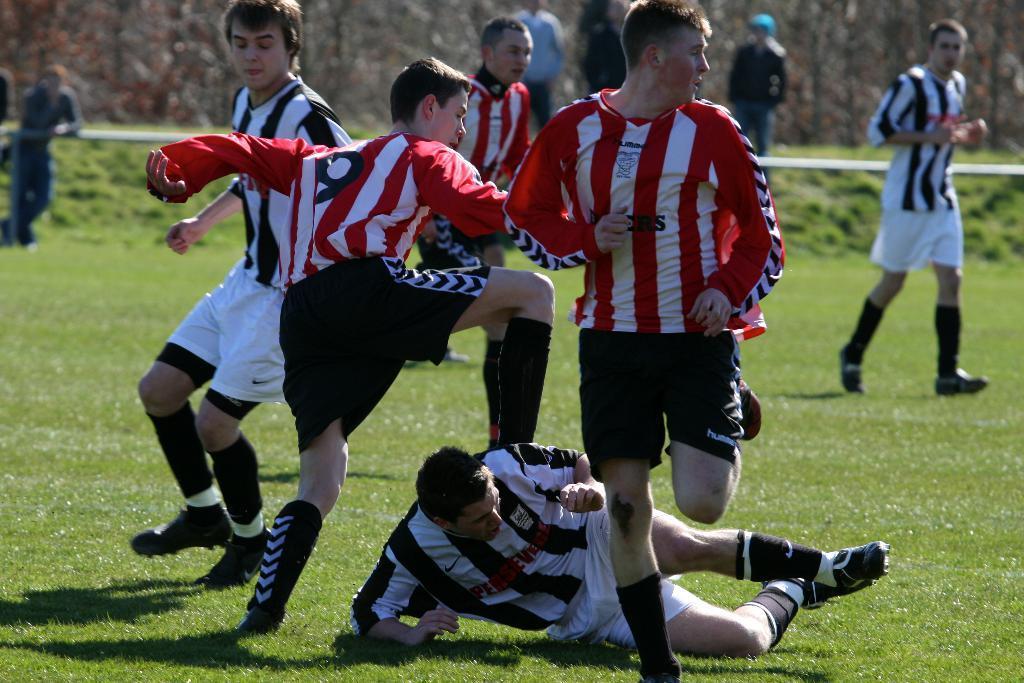Can you describe this image briefly? In this image there are players playing in a ground and a man is lying, in the background there are people standing and there are trees, it is blurred. 